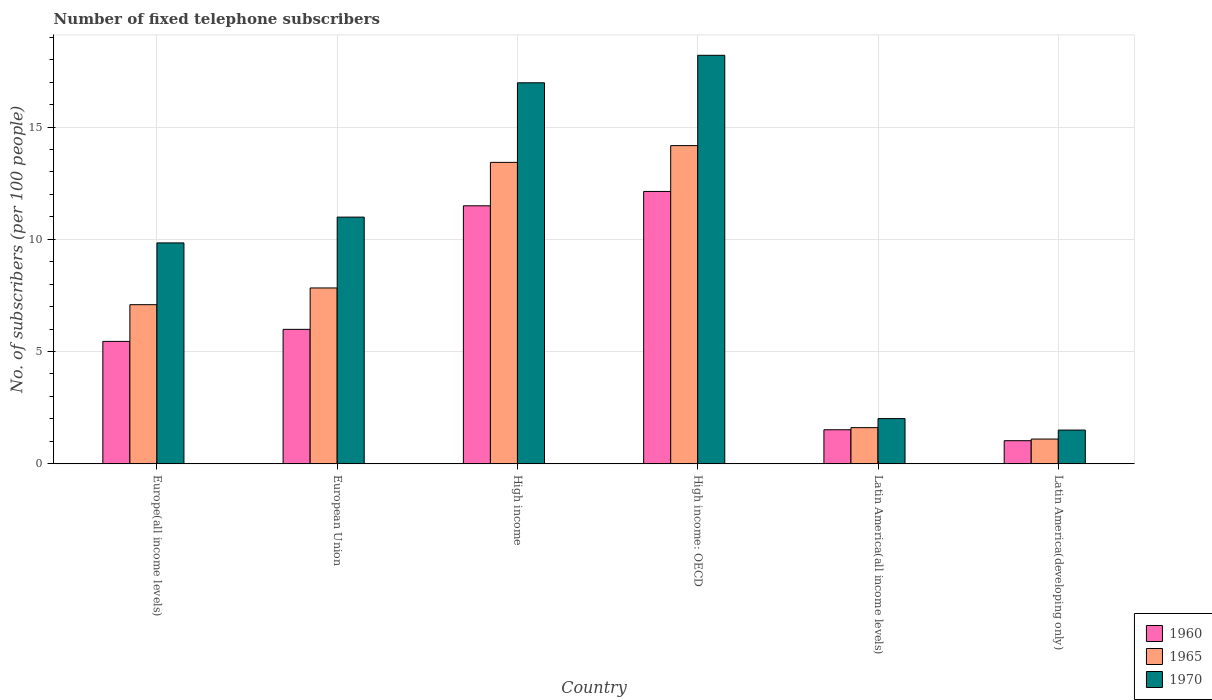How many different coloured bars are there?
Offer a very short reply. 3. What is the label of the 5th group of bars from the left?
Ensure brevity in your answer.  Latin America(all income levels). What is the number of fixed telephone subscribers in 1960 in High income?
Your answer should be very brief. 11.49. Across all countries, what is the maximum number of fixed telephone subscribers in 1970?
Offer a terse response. 18.2. Across all countries, what is the minimum number of fixed telephone subscribers in 1965?
Your answer should be compact. 1.1. In which country was the number of fixed telephone subscribers in 1960 maximum?
Offer a terse response. High income: OECD. In which country was the number of fixed telephone subscribers in 1960 minimum?
Offer a very short reply. Latin America(developing only). What is the total number of fixed telephone subscribers in 1970 in the graph?
Make the answer very short. 59.51. What is the difference between the number of fixed telephone subscribers in 1965 in European Union and that in Latin America(all income levels)?
Keep it short and to the point. 6.22. What is the difference between the number of fixed telephone subscribers in 1970 in High income: OECD and the number of fixed telephone subscribers in 1965 in Latin America(developing only)?
Offer a very short reply. 17.1. What is the average number of fixed telephone subscribers in 1960 per country?
Keep it short and to the point. 6.27. What is the difference between the number of fixed telephone subscribers of/in 1970 and number of fixed telephone subscribers of/in 1960 in Latin America(developing only)?
Your answer should be compact. 0.47. In how many countries, is the number of fixed telephone subscribers in 1960 greater than 16?
Provide a short and direct response. 0. What is the ratio of the number of fixed telephone subscribers in 1960 in European Union to that in High income: OECD?
Your response must be concise. 0.49. Is the number of fixed telephone subscribers in 1965 in Latin America(all income levels) less than that in Latin America(developing only)?
Keep it short and to the point. No. Is the difference between the number of fixed telephone subscribers in 1970 in Europe(all income levels) and Latin America(all income levels) greater than the difference between the number of fixed telephone subscribers in 1960 in Europe(all income levels) and Latin America(all income levels)?
Ensure brevity in your answer.  Yes. What is the difference between the highest and the second highest number of fixed telephone subscribers in 1965?
Your answer should be very brief. -0.75. What is the difference between the highest and the lowest number of fixed telephone subscribers in 1960?
Offer a terse response. 11.1. In how many countries, is the number of fixed telephone subscribers in 1960 greater than the average number of fixed telephone subscribers in 1960 taken over all countries?
Make the answer very short. 2. Is it the case that in every country, the sum of the number of fixed telephone subscribers in 1960 and number of fixed telephone subscribers in 1965 is greater than the number of fixed telephone subscribers in 1970?
Offer a very short reply. Yes. How many bars are there?
Give a very brief answer. 18. How many countries are there in the graph?
Provide a succinct answer. 6. What is the difference between two consecutive major ticks on the Y-axis?
Your answer should be very brief. 5. Does the graph contain any zero values?
Provide a succinct answer. No. Where does the legend appear in the graph?
Ensure brevity in your answer.  Bottom right. How many legend labels are there?
Make the answer very short. 3. How are the legend labels stacked?
Provide a succinct answer. Vertical. What is the title of the graph?
Keep it short and to the point. Number of fixed telephone subscribers. What is the label or title of the Y-axis?
Your answer should be compact. No. of subscribers (per 100 people). What is the No. of subscribers (per 100 people) in 1960 in Europe(all income levels)?
Keep it short and to the point. 5.45. What is the No. of subscribers (per 100 people) in 1965 in Europe(all income levels)?
Make the answer very short. 7.09. What is the No. of subscribers (per 100 people) in 1970 in Europe(all income levels)?
Your response must be concise. 9.84. What is the No. of subscribers (per 100 people) in 1960 in European Union?
Provide a succinct answer. 5.99. What is the No. of subscribers (per 100 people) in 1965 in European Union?
Your answer should be compact. 7.83. What is the No. of subscribers (per 100 people) of 1970 in European Union?
Make the answer very short. 10.99. What is the No. of subscribers (per 100 people) in 1960 in High income?
Your response must be concise. 11.49. What is the No. of subscribers (per 100 people) in 1965 in High income?
Your answer should be very brief. 13.43. What is the No. of subscribers (per 100 people) in 1970 in High income?
Keep it short and to the point. 16.97. What is the No. of subscribers (per 100 people) of 1960 in High income: OECD?
Offer a very short reply. 12.13. What is the No. of subscribers (per 100 people) of 1965 in High income: OECD?
Provide a succinct answer. 14.17. What is the No. of subscribers (per 100 people) of 1970 in High income: OECD?
Your answer should be compact. 18.2. What is the No. of subscribers (per 100 people) of 1960 in Latin America(all income levels)?
Offer a terse response. 1.51. What is the No. of subscribers (per 100 people) in 1965 in Latin America(all income levels)?
Your answer should be very brief. 1.61. What is the No. of subscribers (per 100 people) in 1970 in Latin America(all income levels)?
Make the answer very short. 2.01. What is the No. of subscribers (per 100 people) in 1960 in Latin America(developing only)?
Your answer should be very brief. 1.03. What is the No. of subscribers (per 100 people) in 1965 in Latin America(developing only)?
Offer a very short reply. 1.1. What is the No. of subscribers (per 100 people) in 1970 in Latin America(developing only)?
Provide a short and direct response. 1.5. Across all countries, what is the maximum No. of subscribers (per 100 people) of 1960?
Your response must be concise. 12.13. Across all countries, what is the maximum No. of subscribers (per 100 people) of 1965?
Your answer should be compact. 14.17. Across all countries, what is the maximum No. of subscribers (per 100 people) of 1970?
Offer a very short reply. 18.2. Across all countries, what is the minimum No. of subscribers (per 100 people) of 1960?
Provide a succinct answer. 1.03. Across all countries, what is the minimum No. of subscribers (per 100 people) in 1965?
Offer a very short reply. 1.1. Across all countries, what is the minimum No. of subscribers (per 100 people) in 1970?
Give a very brief answer. 1.5. What is the total No. of subscribers (per 100 people) of 1960 in the graph?
Make the answer very short. 37.6. What is the total No. of subscribers (per 100 people) of 1965 in the graph?
Your answer should be compact. 45.22. What is the total No. of subscribers (per 100 people) of 1970 in the graph?
Offer a very short reply. 59.51. What is the difference between the No. of subscribers (per 100 people) in 1960 in Europe(all income levels) and that in European Union?
Offer a terse response. -0.54. What is the difference between the No. of subscribers (per 100 people) in 1965 in Europe(all income levels) and that in European Union?
Offer a terse response. -0.74. What is the difference between the No. of subscribers (per 100 people) of 1970 in Europe(all income levels) and that in European Union?
Your response must be concise. -1.15. What is the difference between the No. of subscribers (per 100 people) of 1960 in Europe(all income levels) and that in High income?
Make the answer very short. -6.04. What is the difference between the No. of subscribers (per 100 people) of 1965 in Europe(all income levels) and that in High income?
Your answer should be compact. -6.34. What is the difference between the No. of subscribers (per 100 people) in 1970 in Europe(all income levels) and that in High income?
Offer a very short reply. -7.13. What is the difference between the No. of subscribers (per 100 people) of 1960 in Europe(all income levels) and that in High income: OECD?
Give a very brief answer. -6.68. What is the difference between the No. of subscribers (per 100 people) of 1965 in Europe(all income levels) and that in High income: OECD?
Your answer should be compact. -7.09. What is the difference between the No. of subscribers (per 100 people) in 1970 in Europe(all income levels) and that in High income: OECD?
Your response must be concise. -8.36. What is the difference between the No. of subscribers (per 100 people) in 1960 in Europe(all income levels) and that in Latin America(all income levels)?
Keep it short and to the point. 3.94. What is the difference between the No. of subscribers (per 100 people) in 1965 in Europe(all income levels) and that in Latin America(all income levels)?
Your response must be concise. 5.48. What is the difference between the No. of subscribers (per 100 people) of 1970 in Europe(all income levels) and that in Latin America(all income levels)?
Your answer should be very brief. 7.83. What is the difference between the No. of subscribers (per 100 people) in 1960 in Europe(all income levels) and that in Latin America(developing only)?
Ensure brevity in your answer.  4.42. What is the difference between the No. of subscribers (per 100 people) of 1965 in Europe(all income levels) and that in Latin America(developing only)?
Make the answer very short. 5.99. What is the difference between the No. of subscribers (per 100 people) of 1970 in Europe(all income levels) and that in Latin America(developing only)?
Give a very brief answer. 8.34. What is the difference between the No. of subscribers (per 100 people) of 1960 in European Union and that in High income?
Your answer should be very brief. -5.5. What is the difference between the No. of subscribers (per 100 people) of 1965 in European Union and that in High income?
Ensure brevity in your answer.  -5.6. What is the difference between the No. of subscribers (per 100 people) in 1970 in European Union and that in High income?
Your response must be concise. -5.98. What is the difference between the No. of subscribers (per 100 people) in 1960 in European Union and that in High income: OECD?
Keep it short and to the point. -6.14. What is the difference between the No. of subscribers (per 100 people) of 1965 in European Union and that in High income: OECD?
Your answer should be compact. -6.34. What is the difference between the No. of subscribers (per 100 people) of 1970 in European Union and that in High income: OECD?
Make the answer very short. -7.21. What is the difference between the No. of subscribers (per 100 people) in 1960 in European Union and that in Latin America(all income levels)?
Keep it short and to the point. 4.47. What is the difference between the No. of subscribers (per 100 people) in 1965 in European Union and that in Latin America(all income levels)?
Your answer should be very brief. 6.22. What is the difference between the No. of subscribers (per 100 people) in 1970 in European Union and that in Latin America(all income levels)?
Provide a short and direct response. 8.98. What is the difference between the No. of subscribers (per 100 people) in 1960 in European Union and that in Latin America(developing only)?
Make the answer very short. 4.96. What is the difference between the No. of subscribers (per 100 people) in 1965 in European Union and that in Latin America(developing only)?
Ensure brevity in your answer.  6.73. What is the difference between the No. of subscribers (per 100 people) of 1970 in European Union and that in Latin America(developing only)?
Provide a short and direct response. 9.49. What is the difference between the No. of subscribers (per 100 people) in 1960 in High income and that in High income: OECD?
Make the answer very short. -0.64. What is the difference between the No. of subscribers (per 100 people) of 1965 in High income and that in High income: OECD?
Your response must be concise. -0.75. What is the difference between the No. of subscribers (per 100 people) in 1970 in High income and that in High income: OECD?
Make the answer very short. -1.22. What is the difference between the No. of subscribers (per 100 people) of 1960 in High income and that in Latin America(all income levels)?
Make the answer very short. 9.98. What is the difference between the No. of subscribers (per 100 people) in 1965 in High income and that in Latin America(all income levels)?
Offer a very short reply. 11.82. What is the difference between the No. of subscribers (per 100 people) in 1970 in High income and that in Latin America(all income levels)?
Offer a terse response. 14.96. What is the difference between the No. of subscribers (per 100 people) in 1960 in High income and that in Latin America(developing only)?
Keep it short and to the point. 10.46. What is the difference between the No. of subscribers (per 100 people) of 1965 in High income and that in Latin America(developing only)?
Provide a short and direct response. 12.33. What is the difference between the No. of subscribers (per 100 people) in 1970 in High income and that in Latin America(developing only)?
Your answer should be very brief. 15.47. What is the difference between the No. of subscribers (per 100 people) of 1960 in High income: OECD and that in Latin America(all income levels)?
Your answer should be compact. 10.62. What is the difference between the No. of subscribers (per 100 people) in 1965 in High income: OECD and that in Latin America(all income levels)?
Keep it short and to the point. 12.57. What is the difference between the No. of subscribers (per 100 people) of 1970 in High income: OECD and that in Latin America(all income levels)?
Give a very brief answer. 16.19. What is the difference between the No. of subscribers (per 100 people) in 1960 in High income: OECD and that in Latin America(developing only)?
Give a very brief answer. 11.1. What is the difference between the No. of subscribers (per 100 people) of 1965 in High income: OECD and that in Latin America(developing only)?
Give a very brief answer. 13.07. What is the difference between the No. of subscribers (per 100 people) in 1970 in High income: OECD and that in Latin America(developing only)?
Provide a succinct answer. 16.7. What is the difference between the No. of subscribers (per 100 people) of 1960 in Latin America(all income levels) and that in Latin America(developing only)?
Your answer should be very brief. 0.49. What is the difference between the No. of subscribers (per 100 people) in 1965 in Latin America(all income levels) and that in Latin America(developing only)?
Ensure brevity in your answer.  0.51. What is the difference between the No. of subscribers (per 100 people) of 1970 in Latin America(all income levels) and that in Latin America(developing only)?
Offer a terse response. 0.51. What is the difference between the No. of subscribers (per 100 people) in 1960 in Europe(all income levels) and the No. of subscribers (per 100 people) in 1965 in European Union?
Provide a succinct answer. -2.38. What is the difference between the No. of subscribers (per 100 people) of 1960 in Europe(all income levels) and the No. of subscribers (per 100 people) of 1970 in European Union?
Offer a very short reply. -5.54. What is the difference between the No. of subscribers (per 100 people) in 1965 in Europe(all income levels) and the No. of subscribers (per 100 people) in 1970 in European Union?
Your response must be concise. -3.9. What is the difference between the No. of subscribers (per 100 people) in 1960 in Europe(all income levels) and the No. of subscribers (per 100 people) in 1965 in High income?
Your answer should be compact. -7.97. What is the difference between the No. of subscribers (per 100 people) of 1960 in Europe(all income levels) and the No. of subscribers (per 100 people) of 1970 in High income?
Offer a terse response. -11.52. What is the difference between the No. of subscribers (per 100 people) in 1965 in Europe(all income levels) and the No. of subscribers (per 100 people) in 1970 in High income?
Your response must be concise. -9.89. What is the difference between the No. of subscribers (per 100 people) of 1960 in Europe(all income levels) and the No. of subscribers (per 100 people) of 1965 in High income: OECD?
Your response must be concise. -8.72. What is the difference between the No. of subscribers (per 100 people) of 1960 in Europe(all income levels) and the No. of subscribers (per 100 people) of 1970 in High income: OECD?
Keep it short and to the point. -12.75. What is the difference between the No. of subscribers (per 100 people) of 1965 in Europe(all income levels) and the No. of subscribers (per 100 people) of 1970 in High income: OECD?
Ensure brevity in your answer.  -11.11. What is the difference between the No. of subscribers (per 100 people) of 1960 in Europe(all income levels) and the No. of subscribers (per 100 people) of 1965 in Latin America(all income levels)?
Give a very brief answer. 3.84. What is the difference between the No. of subscribers (per 100 people) of 1960 in Europe(all income levels) and the No. of subscribers (per 100 people) of 1970 in Latin America(all income levels)?
Your response must be concise. 3.44. What is the difference between the No. of subscribers (per 100 people) in 1965 in Europe(all income levels) and the No. of subscribers (per 100 people) in 1970 in Latin America(all income levels)?
Your answer should be compact. 5.08. What is the difference between the No. of subscribers (per 100 people) of 1960 in Europe(all income levels) and the No. of subscribers (per 100 people) of 1965 in Latin America(developing only)?
Offer a terse response. 4.35. What is the difference between the No. of subscribers (per 100 people) in 1960 in Europe(all income levels) and the No. of subscribers (per 100 people) in 1970 in Latin America(developing only)?
Your response must be concise. 3.95. What is the difference between the No. of subscribers (per 100 people) in 1965 in Europe(all income levels) and the No. of subscribers (per 100 people) in 1970 in Latin America(developing only)?
Your answer should be very brief. 5.59. What is the difference between the No. of subscribers (per 100 people) in 1960 in European Union and the No. of subscribers (per 100 people) in 1965 in High income?
Make the answer very short. -7.44. What is the difference between the No. of subscribers (per 100 people) in 1960 in European Union and the No. of subscribers (per 100 people) in 1970 in High income?
Keep it short and to the point. -10.99. What is the difference between the No. of subscribers (per 100 people) of 1965 in European Union and the No. of subscribers (per 100 people) of 1970 in High income?
Your answer should be very brief. -9.14. What is the difference between the No. of subscribers (per 100 people) in 1960 in European Union and the No. of subscribers (per 100 people) in 1965 in High income: OECD?
Your answer should be very brief. -8.19. What is the difference between the No. of subscribers (per 100 people) in 1960 in European Union and the No. of subscribers (per 100 people) in 1970 in High income: OECD?
Your answer should be very brief. -12.21. What is the difference between the No. of subscribers (per 100 people) in 1965 in European Union and the No. of subscribers (per 100 people) in 1970 in High income: OECD?
Keep it short and to the point. -10.37. What is the difference between the No. of subscribers (per 100 people) of 1960 in European Union and the No. of subscribers (per 100 people) of 1965 in Latin America(all income levels)?
Your response must be concise. 4.38. What is the difference between the No. of subscribers (per 100 people) in 1960 in European Union and the No. of subscribers (per 100 people) in 1970 in Latin America(all income levels)?
Your answer should be very brief. 3.98. What is the difference between the No. of subscribers (per 100 people) in 1965 in European Union and the No. of subscribers (per 100 people) in 1970 in Latin America(all income levels)?
Offer a very short reply. 5.82. What is the difference between the No. of subscribers (per 100 people) in 1960 in European Union and the No. of subscribers (per 100 people) in 1965 in Latin America(developing only)?
Offer a terse response. 4.89. What is the difference between the No. of subscribers (per 100 people) in 1960 in European Union and the No. of subscribers (per 100 people) in 1970 in Latin America(developing only)?
Give a very brief answer. 4.49. What is the difference between the No. of subscribers (per 100 people) of 1965 in European Union and the No. of subscribers (per 100 people) of 1970 in Latin America(developing only)?
Offer a terse response. 6.33. What is the difference between the No. of subscribers (per 100 people) of 1960 in High income and the No. of subscribers (per 100 people) of 1965 in High income: OECD?
Your answer should be compact. -2.68. What is the difference between the No. of subscribers (per 100 people) in 1960 in High income and the No. of subscribers (per 100 people) in 1970 in High income: OECD?
Your response must be concise. -6.71. What is the difference between the No. of subscribers (per 100 people) of 1965 in High income and the No. of subscribers (per 100 people) of 1970 in High income: OECD?
Provide a succinct answer. -4.77. What is the difference between the No. of subscribers (per 100 people) in 1960 in High income and the No. of subscribers (per 100 people) in 1965 in Latin America(all income levels)?
Make the answer very short. 9.88. What is the difference between the No. of subscribers (per 100 people) in 1960 in High income and the No. of subscribers (per 100 people) in 1970 in Latin America(all income levels)?
Your answer should be compact. 9.48. What is the difference between the No. of subscribers (per 100 people) in 1965 in High income and the No. of subscribers (per 100 people) in 1970 in Latin America(all income levels)?
Offer a terse response. 11.42. What is the difference between the No. of subscribers (per 100 people) of 1960 in High income and the No. of subscribers (per 100 people) of 1965 in Latin America(developing only)?
Keep it short and to the point. 10.39. What is the difference between the No. of subscribers (per 100 people) of 1960 in High income and the No. of subscribers (per 100 people) of 1970 in Latin America(developing only)?
Give a very brief answer. 9.99. What is the difference between the No. of subscribers (per 100 people) of 1965 in High income and the No. of subscribers (per 100 people) of 1970 in Latin America(developing only)?
Offer a very short reply. 11.93. What is the difference between the No. of subscribers (per 100 people) in 1960 in High income: OECD and the No. of subscribers (per 100 people) in 1965 in Latin America(all income levels)?
Ensure brevity in your answer.  10.52. What is the difference between the No. of subscribers (per 100 people) of 1960 in High income: OECD and the No. of subscribers (per 100 people) of 1970 in Latin America(all income levels)?
Your answer should be compact. 10.12. What is the difference between the No. of subscribers (per 100 people) of 1965 in High income: OECD and the No. of subscribers (per 100 people) of 1970 in Latin America(all income levels)?
Offer a very short reply. 12.16. What is the difference between the No. of subscribers (per 100 people) of 1960 in High income: OECD and the No. of subscribers (per 100 people) of 1965 in Latin America(developing only)?
Ensure brevity in your answer.  11.03. What is the difference between the No. of subscribers (per 100 people) in 1960 in High income: OECD and the No. of subscribers (per 100 people) in 1970 in Latin America(developing only)?
Offer a very short reply. 10.63. What is the difference between the No. of subscribers (per 100 people) in 1965 in High income: OECD and the No. of subscribers (per 100 people) in 1970 in Latin America(developing only)?
Offer a very short reply. 12.67. What is the difference between the No. of subscribers (per 100 people) of 1960 in Latin America(all income levels) and the No. of subscribers (per 100 people) of 1965 in Latin America(developing only)?
Make the answer very short. 0.41. What is the difference between the No. of subscribers (per 100 people) in 1960 in Latin America(all income levels) and the No. of subscribers (per 100 people) in 1970 in Latin America(developing only)?
Keep it short and to the point. 0.01. What is the difference between the No. of subscribers (per 100 people) in 1965 in Latin America(all income levels) and the No. of subscribers (per 100 people) in 1970 in Latin America(developing only)?
Your answer should be very brief. 0.11. What is the average No. of subscribers (per 100 people) in 1960 per country?
Offer a terse response. 6.27. What is the average No. of subscribers (per 100 people) of 1965 per country?
Make the answer very short. 7.54. What is the average No. of subscribers (per 100 people) of 1970 per country?
Give a very brief answer. 9.92. What is the difference between the No. of subscribers (per 100 people) in 1960 and No. of subscribers (per 100 people) in 1965 in Europe(all income levels)?
Ensure brevity in your answer.  -1.64. What is the difference between the No. of subscribers (per 100 people) of 1960 and No. of subscribers (per 100 people) of 1970 in Europe(all income levels)?
Give a very brief answer. -4.39. What is the difference between the No. of subscribers (per 100 people) of 1965 and No. of subscribers (per 100 people) of 1970 in Europe(all income levels)?
Your answer should be compact. -2.75. What is the difference between the No. of subscribers (per 100 people) in 1960 and No. of subscribers (per 100 people) in 1965 in European Union?
Keep it short and to the point. -1.84. What is the difference between the No. of subscribers (per 100 people) of 1960 and No. of subscribers (per 100 people) of 1970 in European Union?
Your response must be concise. -5. What is the difference between the No. of subscribers (per 100 people) of 1965 and No. of subscribers (per 100 people) of 1970 in European Union?
Provide a short and direct response. -3.16. What is the difference between the No. of subscribers (per 100 people) in 1960 and No. of subscribers (per 100 people) in 1965 in High income?
Your response must be concise. -1.93. What is the difference between the No. of subscribers (per 100 people) of 1960 and No. of subscribers (per 100 people) of 1970 in High income?
Provide a succinct answer. -5.48. What is the difference between the No. of subscribers (per 100 people) in 1965 and No. of subscribers (per 100 people) in 1970 in High income?
Offer a very short reply. -3.55. What is the difference between the No. of subscribers (per 100 people) in 1960 and No. of subscribers (per 100 people) in 1965 in High income: OECD?
Offer a very short reply. -2.04. What is the difference between the No. of subscribers (per 100 people) of 1960 and No. of subscribers (per 100 people) of 1970 in High income: OECD?
Your response must be concise. -6.07. What is the difference between the No. of subscribers (per 100 people) in 1965 and No. of subscribers (per 100 people) in 1970 in High income: OECD?
Offer a very short reply. -4.02. What is the difference between the No. of subscribers (per 100 people) of 1960 and No. of subscribers (per 100 people) of 1965 in Latin America(all income levels)?
Offer a terse response. -0.09. What is the difference between the No. of subscribers (per 100 people) of 1960 and No. of subscribers (per 100 people) of 1970 in Latin America(all income levels)?
Offer a terse response. -0.5. What is the difference between the No. of subscribers (per 100 people) in 1965 and No. of subscribers (per 100 people) in 1970 in Latin America(all income levels)?
Your response must be concise. -0.4. What is the difference between the No. of subscribers (per 100 people) of 1960 and No. of subscribers (per 100 people) of 1965 in Latin America(developing only)?
Offer a very short reply. -0.07. What is the difference between the No. of subscribers (per 100 people) of 1960 and No. of subscribers (per 100 people) of 1970 in Latin America(developing only)?
Offer a very short reply. -0.47. What is the difference between the No. of subscribers (per 100 people) in 1965 and No. of subscribers (per 100 people) in 1970 in Latin America(developing only)?
Offer a very short reply. -0.4. What is the ratio of the No. of subscribers (per 100 people) in 1960 in Europe(all income levels) to that in European Union?
Offer a terse response. 0.91. What is the ratio of the No. of subscribers (per 100 people) of 1965 in Europe(all income levels) to that in European Union?
Keep it short and to the point. 0.91. What is the ratio of the No. of subscribers (per 100 people) in 1970 in Europe(all income levels) to that in European Union?
Give a very brief answer. 0.9. What is the ratio of the No. of subscribers (per 100 people) in 1960 in Europe(all income levels) to that in High income?
Offer a very short reply. 0.47. What is the ratio of the No. of subscribers (per 100 people) of 1965 in Europe(all income levels) to that in High income?
Give a very brief answer. 0.53. What is the ratio of the No. of subscribers (per 100 people) of 1970 in Europe(all income levels) to that in High income?
Your answer should be compact. 0.58. What is the ratio of the No. of subscribers (per 100 people) in 1960 in Europe(all income levels) to that in High income: OECD?
Make the answer very short. 0.45. What is the ratio of the No. of subscribers (per 100 people) in 1965 in Europe(all income levels) to that in High income: OECD?
Provide a succinct answer. 0.5. What is the ratio of the No. of subscribers (per 100 people) of 1970 in Europe(all income levels) to that in High income: OECD?
Provide a succinct answer. 0.54. What is the ratio of the No. of subscribers (per 100 people) of 1960 in Europe(all income levels) to that in Latin America(all income levels)?
Keep it short and to the point. 3.6. What is the ratio of the No. of subscribers (per 100 people) in 1965 in Europe(all income levels) to that in Latin America(all income levels)?
Make the answer very short. 4.41. What is the ratio of the No. of subscribers (per 100 people) in 1970 in Europe(all income levels) to that in Latin America(all income levels)?
Your answer should be compact. 4.89. What is the ratio of the No. of subscribers (per 100 people) of 1960 in Europe(all income levels) to that in Latin America(developing only)?
Offer a very short reply. 5.31. What is the ratio of the No. of subscribers (per 100 people) of 1965 in Europe(all income levels) to that in Latin America(developing only)?
Ensure brevity in your answer.  6.45. What is the ratio of the No. of subscribers (per 100 people) of 1970 in Europe(all income levels) to that in Latin America(developing only)?
Your response must be concise. 6.56. What is the ratio of the No. of subscribers (per 100 people) in 1960 in European Union to that in High income?
Provide a succinct answer. 0.52. What is the ratio of the No. of subscribers (per 100 people) in 1965 in European Union to that in High income?
Your answer should be very brief. 0.58. What is the ratio of the No. of subscribers (per 100 people) of 1970 in European Union to that in High income?
Offer a very short reply. 0.65. What is the ratio of the No. of subscribers (per 100 people) of 1960 in European Union to that in High income: OECD?
Your response must be concise. 0.49. What is the ratio of the No. of subscribers (per 100 people) of 1965 in European Union to that in High income: OECD?
Your answer should be compact. 0.55. What is the ratio of the No. of subscribers (per 100 people) of 1970 in European Union to that in High income: OECD?
Keep it short and to the point. 0.6. What is the ratio of the No. of subscribers (per 100 people) in 1960 in European Union to that in Latin America(all income levels)?
Your response must be concise. 3.95. What is the ratio of the No. of subscribers (per 100 people) in 1965 in European Union to that in Latin America(all income levels)?
Your answer should be very brief. 4.87. What is the ratio of the No. of subscribers (per 100 people) of 1970 in European Union to that in Latin America(all income levels)?
Provide a short and direct response. 5.46. What is the ratio of the No. of subscribers (per 100 people) in 1960 in European Union to that in Latin America(developing only)?
Give a very brief answer. 5.83. What is the ratio of the No. of subscribers (per 100 people) in 1965 in European Union to that in Latin America(developing only)?
Provide a succinct answer. 7.12. What is the ratio of the No. of subscribers (per 100 people) in 1970 in European Union to that in Latin America(developing only)?
Keep it short and to the point. 7.32. What is the ratio of the No. of subscribers (per 100 people) in 1960 in High income to that in High income: OECD?
Your answer should be very brief. 0.95. What is the ratio of the No. of subscribers (per 100 people) of 1965 in High income to that in High income: OECD?
Provide a short and direct response. 0.95. What is the ratio of the No. of subscribers (per 100 people) of 1970 in High income to that in High income: OECD?
Keep it short and to the point. 0.93. What is the ratio of the No. of subscribers (per 100 people) in 1960 in High income to that in Latin America(all income levels)?
Offer a very short reply. 7.59. What is the ratio of the No. of subscribers (per 100 people) in 1965 in High income to that in Latin America(all income levels)?
Your answer should be very brief. 8.35. What is the ratio of the No. of subscribers (per 100 people) in 1970 in High income to that in Latin America(all income levels)?
Provide a short and direct response. 8.44. What is the ratio of the No. of subscribers (per 100 people) of 1960 in High income to that in Latin America(developing only)?
Provide a short and direct response. 11.19. What is the ratio of the No. of subscribers (per 100 people) in 1965 in High income to that in Latin America(developing only)?
Offer a terse response. 12.21. What is the ratio of the No. of subscribers (per 100 people) in 1970 in High income to that in Latin America(developing only)?
Give a very brief answer. 11.31. What is the ratio of the No. of subscribers (per 100 people) in 1960 in High income: OECD to that in Latin America(all income levels)?
Offer a terse response. 8.01. What is the ratio of the No. of subscribers (per 100 people) of 1965 in High income: OECD to that in Latin America(all income levels)?
Ensure brevity in your answer.  8.82. What is the ratio of the No. of subscribers (per 100 people) of 1970 in High income: OECD to that in Latin America(all income levels)?
Your answer should be very brief. 9.05. What is the ratio of the No. of subscribers (per 100 people) in 1960 in High income: OECD to that in Latin America(developing only)?
Your answer should be compact. 11.82. What is the ratio of the No. of subscribers (per 100 people) of 1965 in High income: OECD to that in Latin America(developing only)?
Give a very brief answer. 12.89. What is the ratio of the No. of subscribers (per 100 people) of 1970 in High income: OECD to that in Latin America(developing only)?
Give a very brief answer. 12.13. What is the ratio of the No. of subscribers (per 100 people) in 1960 in Latin America(all income levels) to that in Latin America(developing only)?
Offer a terse response. 1.47. What is the ratio of the No. of subscribers (per 100 people) of 1965 in Latin America(all income levels) to that in Latin America(developing only)?
Provide a succinct answer. 1.46. What is the ratio of the No. of subscribers (per 100 people) of 1970 in Latin America(all income levels) to that in Latin America(developing only)?
Your response must be concise. 1.34. What is the difference between the highest and the second highest No. of subscribers (per 100 people) of 1960?
Make the answer very short. 0.64. What is the difference between the highest and the second highest No. of subscribers (per 100 people) in 1965?
Ensure brevity in your answer.  0.75. What is the difference between the highest and the second highest No. of subscribers (per 100 people) of 1970?
Offer a terse response. 1.22. What is the difference between the highest and the lowest No. of subscribers (per 100 people) in 1960?
Provide a succinct answer. 11.1. What is the difference between the highest and the lowest No. of subscribers (per 100 people) of 1965?
Give a very brief answer. 13.07. What is the difference between the highest and the lowest No. of subscribers (per 100 people) in 1970?
Ensure brevity in your answer.  16.7. 